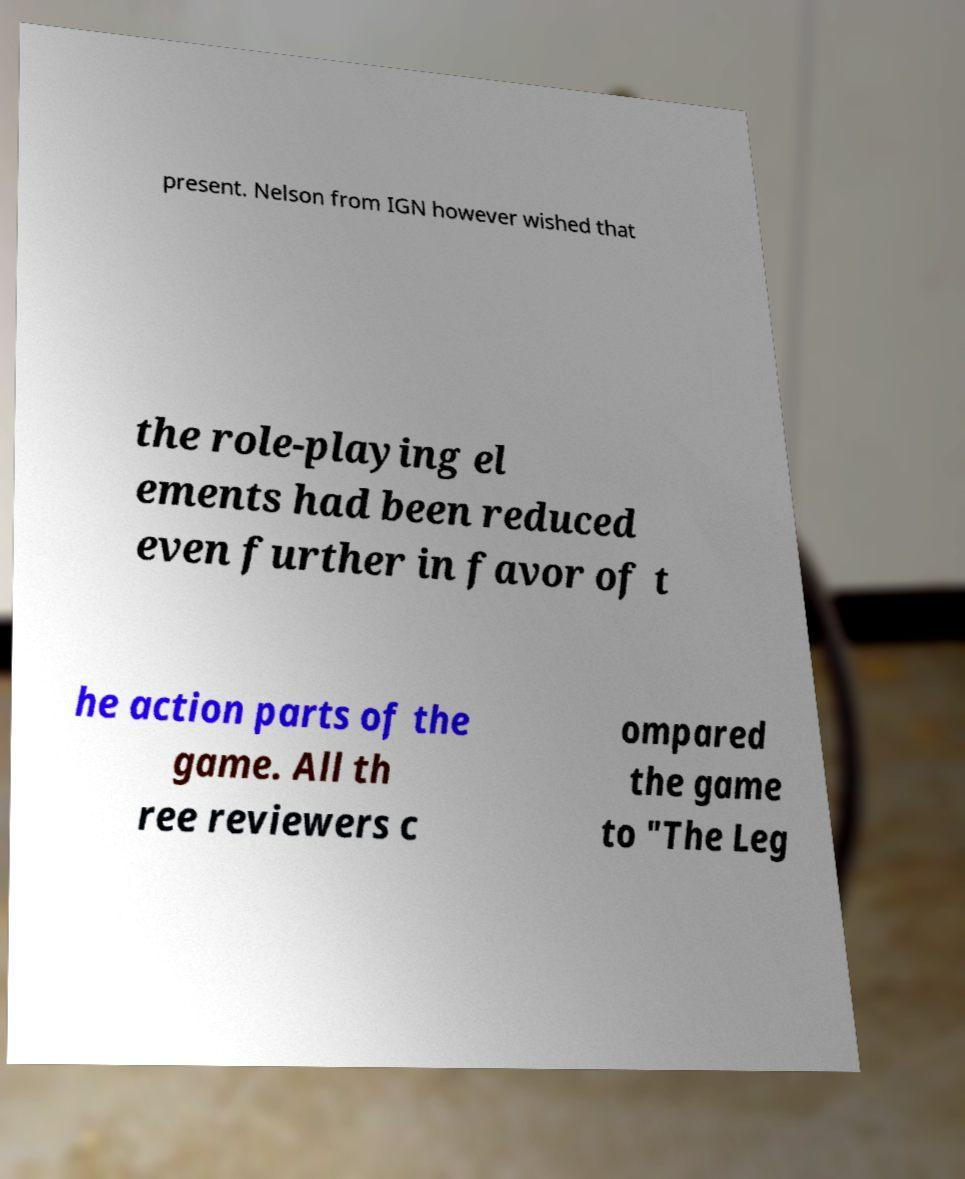What messages or text are displayed in this image? I need them in a readable, typed format. present. Nelson from IGN however wished that the role-playing el ements had been reduced even further in favor of t he action parts of the game. All th ree reviewers c ompared the game to "The Leg 